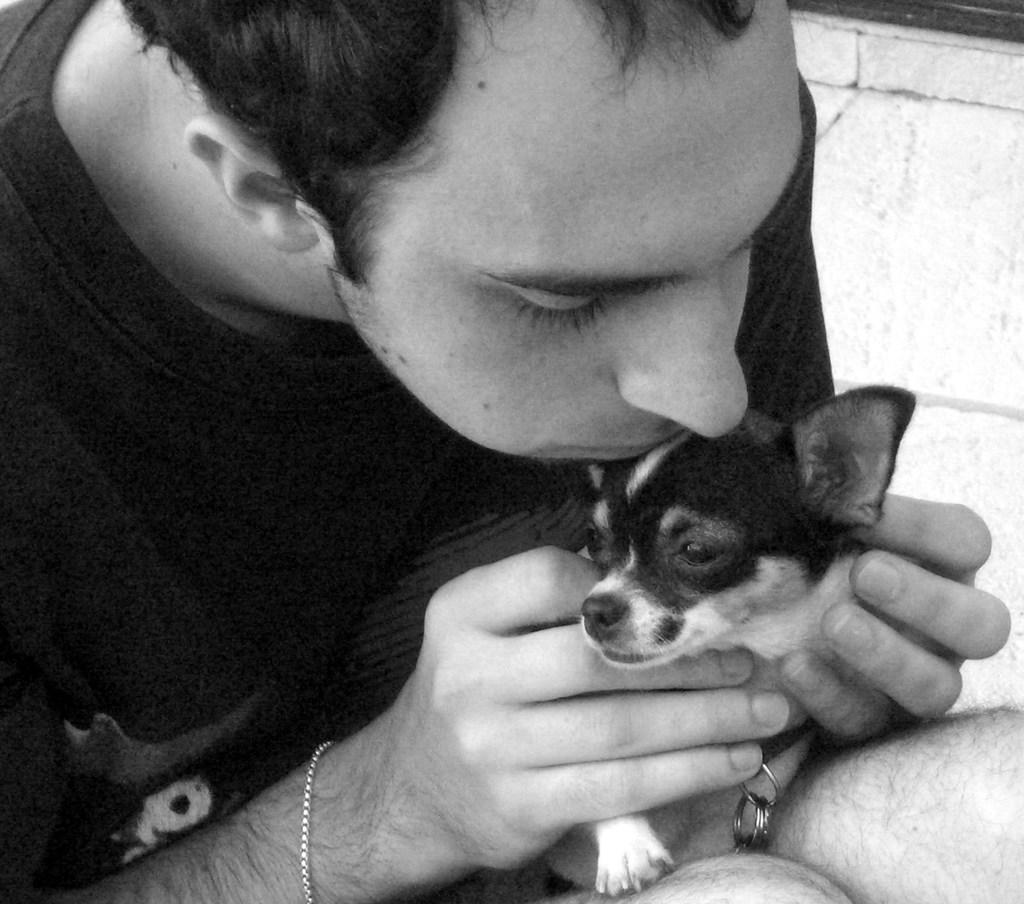What is the main subject of the image? The main subject of the image is a man. What is the man doing in the image? The man is holding a dog in his hands. What is the man's reaction to the baby in the image? There is no baby present in the image. What type of plane is flying in the background of the image? There is no plane visible in the image. 